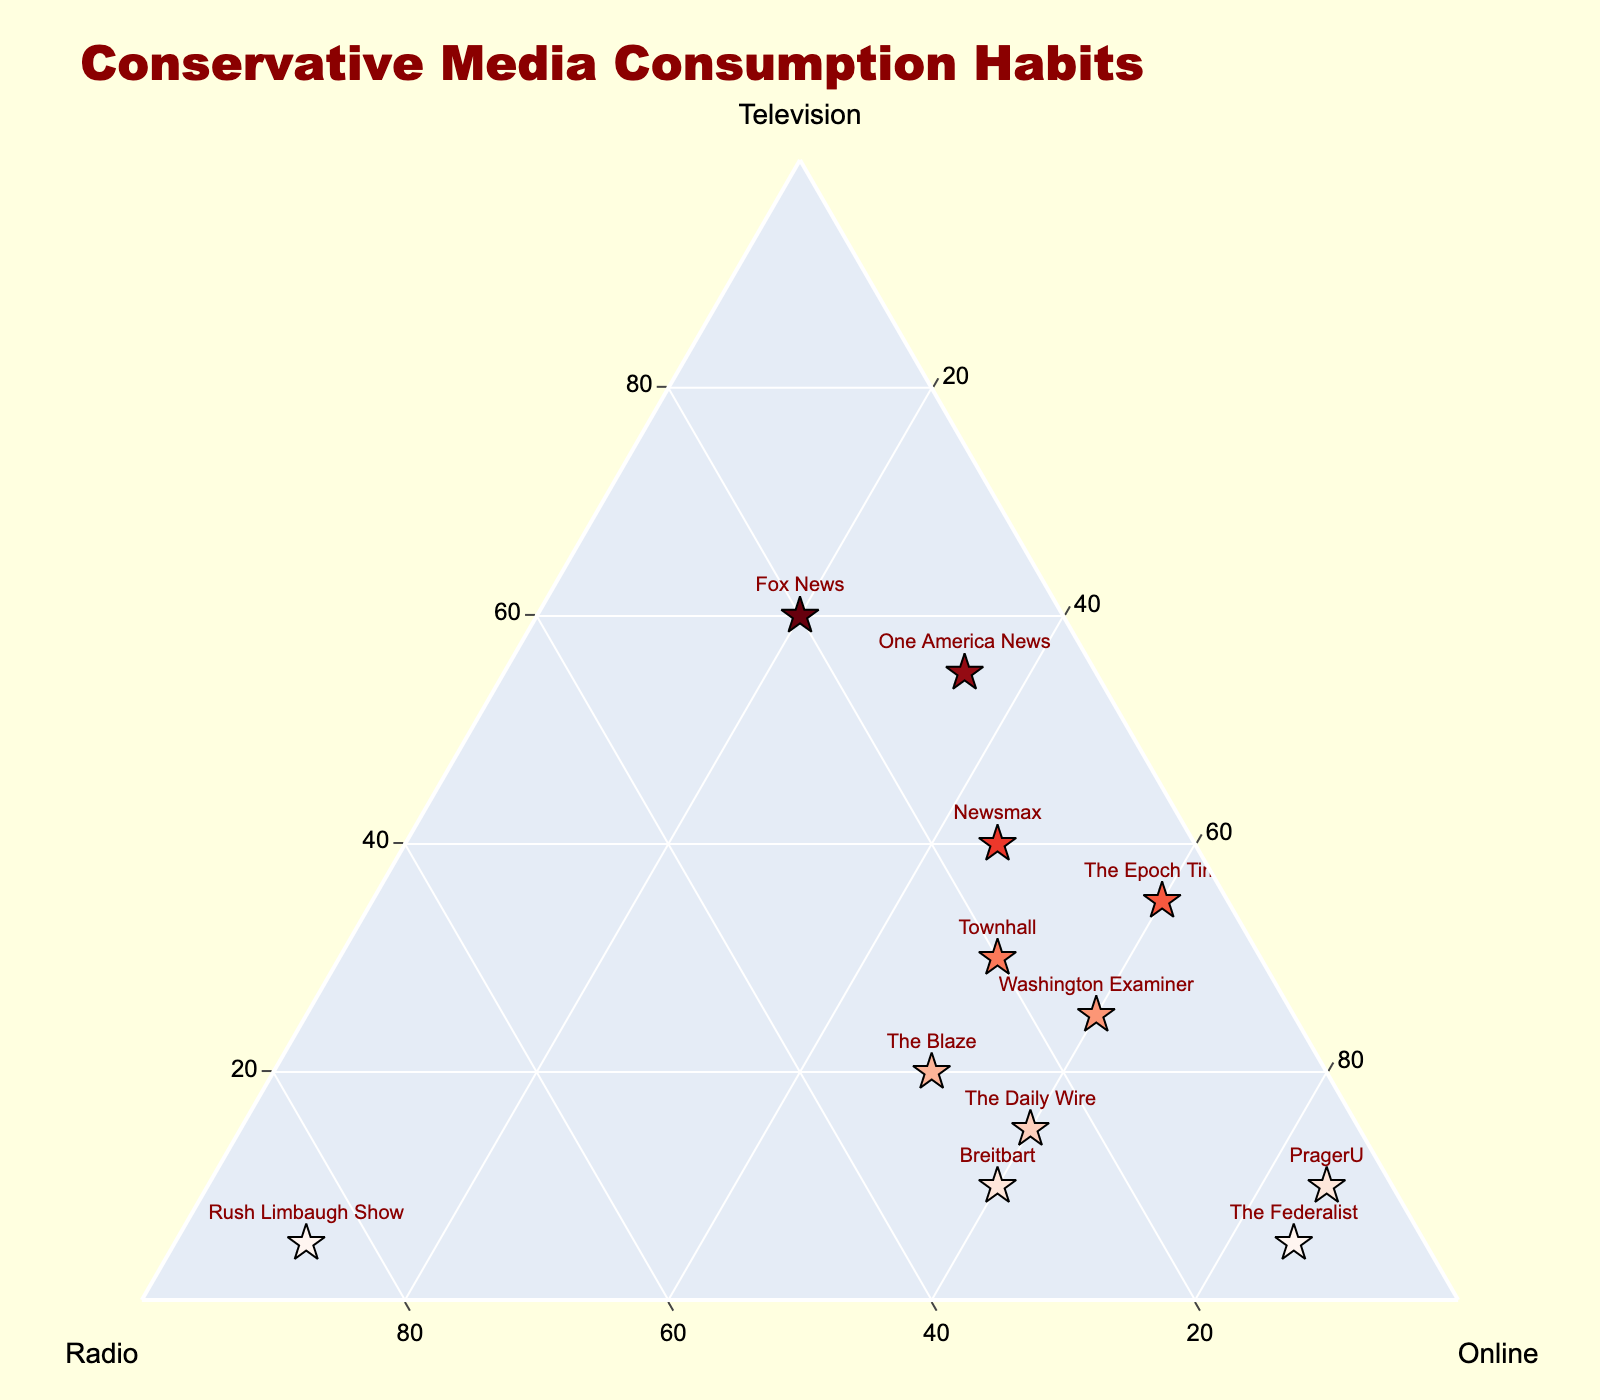Which media source has the highest proportion of online consumption? The media source with the highest proportion of online consumption appears at the apex of the triangle representing 'Online'. "PragerU" has the highest percentage with 85% online consumption.
Answer: PragerU Which source relies least on radio? The source with the smallest percentage closest to zero on the 'Radio' axis represents the least reliance on radio. "PragerU" and "The Epoch Times" both rely only 5% on radio.
Answer: PragerU, The Epoch Times What media source has the highest proportion of radio consumption? The media source at the apex of the triangle representing 'Radio' shows the highest proportion of radio consumption. "Rush Limbaugh Show" has the highest radio consumption at 85%.
Answer: Rush Limbaugh Show Which media source has a balanced consumption across all three media types? Look for a source where the proportions of television, radio, and online are relatively equal. "Fox News" has a balanced distribution with 60% television, 20% radio, and 20% online.
Answer: Fox News How does the usage of radio compare between "Breitbart" and "Washington Examiner"? Observe the positions on the 'Radio' axis for "Breitbart" and "Washington Examiner". "Breitbart" has 30% radio while "Washington Examiner" has 15%. This makes "Breitbart" higher by 15%.
Answer: Breitbart has 15% more Which media source has the highest television consumption but the lowest online consumption? Look for the source closest to the television apex but farthest from the online apex. "Fox News" has the highest television (60%) but relatively low online (20%).
Answer: Fox News Are there any sources with more than 50% consumption from two different media types? Check if any media source has percentages above 50% in two of the three categories. None of the sources meet this criterion from the given data.
Answer: No Based on the plot, which sources have exactly 60% online consumption? Look for media sources plotted where the online axis indicates 60%. "Breitbart", "The Daily Wire", "Washington Examiner", and "The Epoch Times" each have 60% online.
Answer: Breitbart, The Daily Wire, Washington Examiner, The Epoch Times 